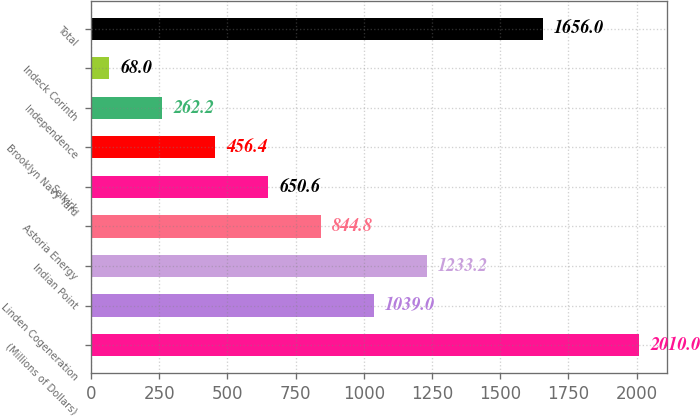Convert chart to OTSL. <chart><loc_0><loc_0><loc_500><loc_500><bar_chart><fcel>(Millions of Dollars)<fcel>Linden Cogeneration<fcel>Indian Point<fcel>Astoria Energy<fcel>Selkirk<fcel>Brooklyn Navy Yard<fcel>Independence<fcel>Indeck Corinth<fcel>Total<nl><fcel>2010<fcel>1039<fcel>1233.2<fcel>844.8<fcel>650.6<fcel>456.4<fcel>262.2<fcel>68<fcel>1656<nl></chart> 